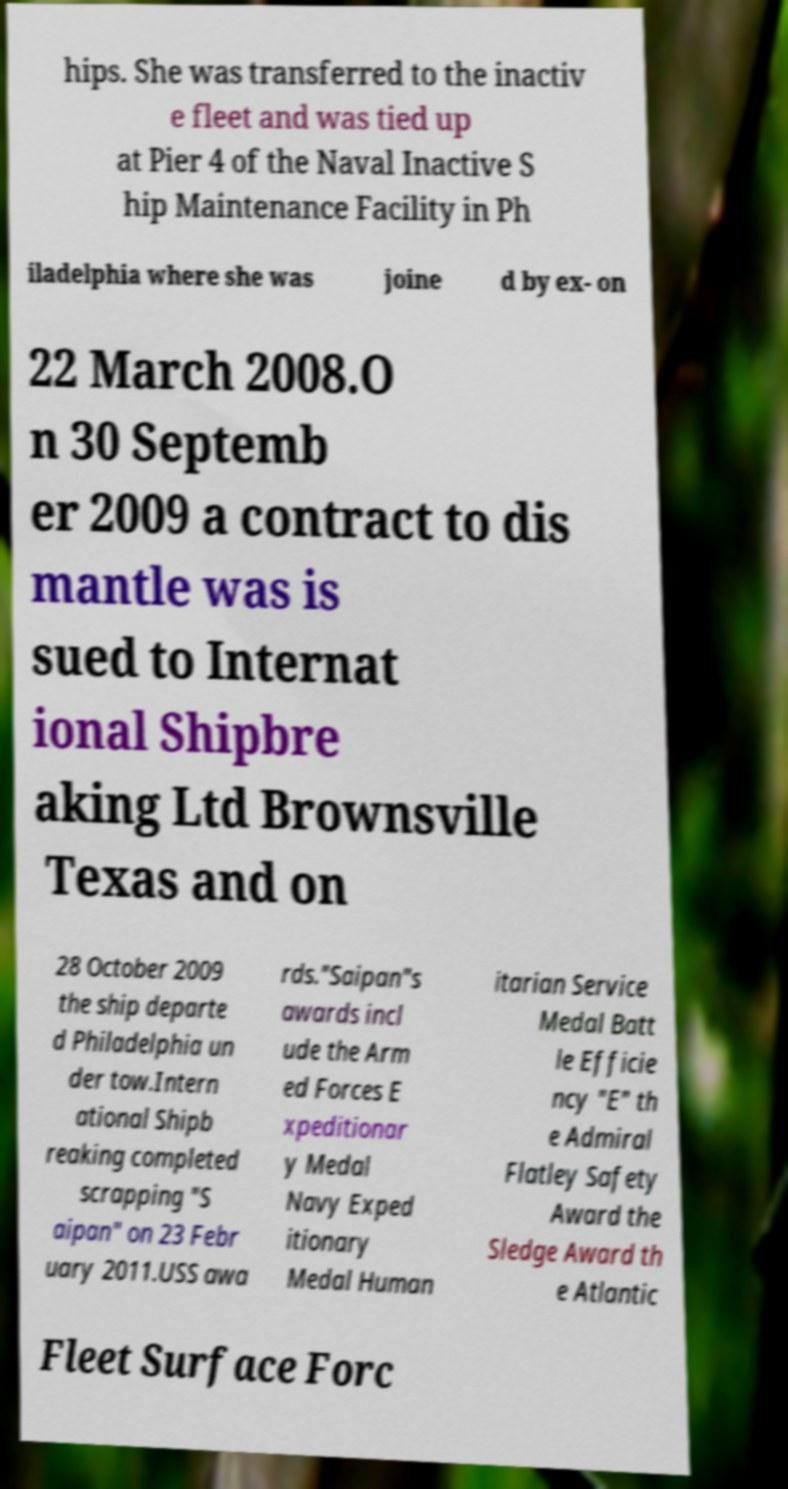I need the written content from this picture converted into text. Can you do that? hips. She was transferred to the inactiv e fleet and was tied up at Pier 4 of the Naval Inactive S hip Maintenance Facility in Ph iladelphia where she was joine d by ex- on 22 March 2008.O n 30 Septemb er 2009 a contract to dis mantle was is sued to Internat ional Shipbre aking Ltd Brownsville Texas and on 28 October 2009 the ship departe d Philadelphia un der tow.Intern ational Shipb reaking completed scrapping "S aipan" on 23 Febr uary 2011.USS awa rds."Saipan"s awards incl ude the Arm ed Forces E xpeditionar y Medal Navy Exped itionary Medal Human itarian Service Medal Batt le Efficie ncy "E" th e Admiral Flatley Safety Award the Sledge Award th e Atlantic Fleet Surface Forc 